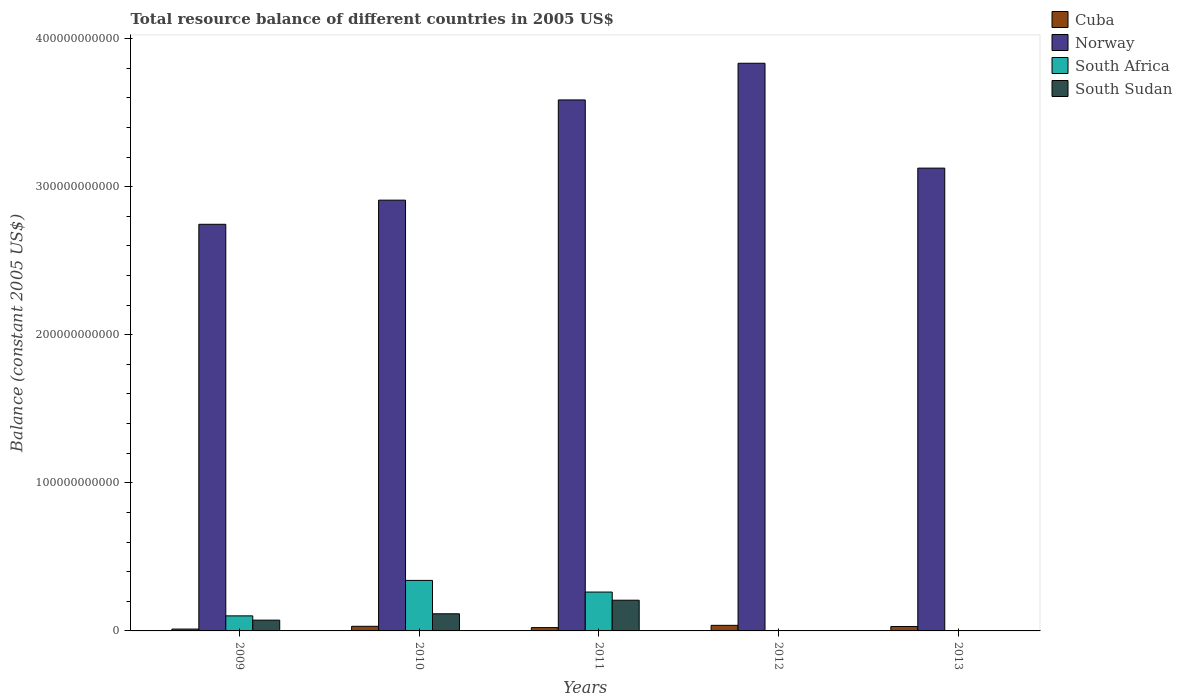How many different coloured bars are there?
Ensure brevity in your answer.  4. Are the number of bars per tick equal to the number of legend labels?
Offer a terse response. No. Are the number of bars on each tick of the X-axis equal?
Your response must be concise. No. What is the total resource balance in Norway in 2009?
Provide a short and direct response. 2.75e+11. Across all years, what is the maximum total resource balance in Cuba?
Offer a very short reply. 3.77e+09. Across all years, what is the minimum total resource balance in Cuba?
Your answer should be very brief. 1.25e+09. What is the total total resource balance in South Sudan in the graph?
Your answer should be compact. 3.96e+1. What is the difference between the total resource balance in Cuba in 2010 and that in 2012?
Provide a succinct answer. -6.53e+08. What is the difference between the total resource balance in Cuba in 2011 and the total resource balance in South Sudan in 2012?
Offer a terse response. 2.24e+09. What is the average total resource balance in South Sudan per year?
Provide a succinct answer. 7.92e+09. In the year 2010, what is the difference between the total resource balance in South Sudan and total resource balance in Cuba?
Offer a terse response. 8.45e+09. What is the ratio of the total resource balance in Norway in 2010 to that in 2012?
Offer a terse response. 0.76. Is the total resource balance in Cuba in 2011 less than that in 2013?
Offer a very short reply. Yes. What is the difference between the highest and the second highest total resource balance in South Sudan?
Make the answer very short. 9.17e+09. What is the difference between the highest and the lowest total resource balance in South Sudan?
Offer a terse response. 2.07e+1. In how many years, is the total resource balance in South Africa greater than the average total resource balance in South Africa taken over all years?
Your answer should be compact. 2. Is the sum of the total resource balance in South Africa in 2009 and 2010 greater than the maximum total resource balance in Norway across all years?
Provide a succinct answer. No. Is it the case that in every year, the sum of the total resource balance in South Africa and total resource balance in Cuba is greater than the sum of total resource balance in South Sudan and total resource balance in Norway?
Offer a very short reply. No. How many bars are there?
Your answer should be compact. 16. What is the difference between two consecutive major ticks on the Y-axis?
Ensure brevity in your answer.  1.00e+11. Are the values on the major ticks of Y-axis written in scientific E-notation?
Offer a very short reply. No. How many legend labels are there?
Your response must be concise. 4. How are the legend labels stacked?
Ensure brevity in your answer.  Vertical. What is the title of the graph?
Provide a succinct answer. Total resource balance of different countries in 2005 US$. Does "American Samoa" appear as one of the legend labels in the graph?
Provide a succinct answer. No. What is the label or title of the X-axis?
Keep it short and to the point. Years. What is the label or title of the Y-axis?
Provide a succinct answer. Balance (constant 2005 US$). What is the Balance (constant 2005 US$) of Cuba in 2009?
Offer a terse response. 1.25e+09. What is the Balance (constant 2005 US$) of Norway in 2009?
Give a very brief answer. 2.75e+11. What is the Balance (constant 2005 US$) of South Africa in 2009?
Ensure brevity in your answer.  1.02e+1. What is the Balance (constant 2005 US$) of South Sudan in 2009?
Your response must be concise. 7.29e+09. What is the Balance (constant 2005 US$) in Cuba in 2010?
Offer a very short reply. 3.12e+09. What is the Balance (constant 2005 US$) in Norway in 2010?
Provide a short and direct response. 2.91e+11. What is the Balance (constant 2005 US$) of South Africa in 2010?
Give a very brief answer. 3.41e+1. What is the Balance (constant 2005 US$) in South Sudan in 2010?
Give a very brief answer. 1.16e+1. What is the Balance (constant 2005 US$) in Cuba in 2011?
Offer a very short reply. 2.24e+09. What is the Balance (constant 2005 US$) in Norway in 2011?
Give a very brief answer. 3.59e+11. What is the Balance (constant 2005 US$) in South Africa in 2011?
Make the answer very short. 2.62e+1. What is the Balance (constant 2005 US$) of South Sudan in 2011?
Offer a very short reply. 2.07e+1. What is the Balance (constant 2005 US$) of Cuba in 2012?
Provide a succinct answer. 3.77e+09. What is the Balance (constant 2005 US$) in Norway in 2012?
Provide a short and direct response. 3.83e+11. What is the Balance (constant 2005 US$) in Cuba in 2013?
Offer a very short reply. 2.99e+09. What is the Balance (constant 2005 US$) of Norway in 2013?
Make the answer very short. 3.13e+11. What is the Balance (constant 2005 US$) of South Africa in 2013?
Your answer should be compact. 0. Across all years, what is the maximum Balance (constant 2005 US$) of Cuba?
Provide a short and direct response. 3.77e+09. Across all years, what is the maximum Balance (constant 2005 US$) of Norway?
Provide a short and direct response. 3.83e+11. Across all years, what is the maximum Balance (constant 2005 US$) of South Africa?
Offer a very short reply. 3.41e+1. Across all years, what is the maximum Balance (constant 2005 US$) in South Sudan?
Keep it short and to the point. 2.07e+1. Across all years, what is the minimum Balance (constant 2005 US$) of Cuba?
Provide a succinct answer. 1.25e+09. Across all years, what is the minimum Balance (constant 2005 US$) of Norway?
Offer a terse response. 2.75e+11. Across all years, what is the minimum Balance (constant 2005 US$) in South Africa?
Offer a terse response. 0. What is the total Balance (constant 2005 US$) of Cuba in the graph?
Your response must be concise. 1.34e+1. What is the total Balance (constant 2005 US$) in Norway in the graph?
Make the answer very short. 1.62e+12. What is the total Balance (constant 2005 US$) in South Africa in the graph?
Give a very brief answer. 7.05e+1. What is the total Balance (constant 2005 US$) of South Sudan in the graph?
Give a very brief answer. 3.96e+1. What is the difference between the Balance (constant 2005 US$) in Cuba in 2009 and that in 2010?
Make the answer very short. -1.87e+09. What is the difference between the Balance (constant 2005 US$) of Norway in 2009 and that in 2010?
Provide a short and direct response. -1.63e+1. What is the difference between the Balance (constant 2005 US$) in South Africa in 2009 and that in 2010?
Your answer should be compact. -2.39e+1. What is the difference between the Balance (constant 2005 US$) of South Sudan in 2009 and that in 2010?
Make the answer very short. -4.29e+09. What is the difference between the Balance (constant 2005 US$) in Cuba in 2009 and that in 2011?
Offer a very short reply. -9.94e+08. What is the difference between the Balance (constant 2005 US$) of Norway in 2009 and that in 2011?
Make the answer very short. -8.40e+1. What is the difference between the Balance (constant 2005 US$) in South Africa in 2009 and that in 2011?
Offer a very short reply. -1.61e+1. What is the difference between the Balance (constant 2005 US$) in South Sudan in 2009 and that in 2011?
Ensure brevity in your answer.  -1.35e+1. What is the difference between the Balance (constant 2005 US$) in Cuba in 2009 and that in 2012?
Offer a very short reply. -2.53e+09. What is the difference between the Balance (constant 2005 US$) of Norway in 2009 and that in 2012?
Your answer should be compact. -1.09e+11. What is the difference between the Balance (constant 2005 US$) of Cuba in 2009 and that in 2013?
Offer a terse response. -1.75e+09. What is the difference between the Balance (constant 2005 US$) of Norway in 2009 and that in 2013?
Ensure brevity in your answer.  -3.79e+1. What is the difference between the Balance (constant 2005 US$) of Cuba in 2010 and that in 2011?
Provide a short and direct response. 8.79e+08. What is the difference between the Balance (constant 2005 US$) of Norway in 2010 and that in 2011?
Provide a succinct answer. -6.77e+1. What is the difference between the Balance (constant 2005 US$) in South Africa in 2010 and that in 2011?
Make the answer very short. 7.87e+09. What is the difference between the Balance (constant 2005 US$) of South Sudan in 2010 and that in 2011?
Your answer should be very brief. -9.17e+09. What is the difference between the Balance (constant 2005 US$) of Cuba in 2010 and that in 2012?
Your response must be concise. -6.53e+08. What is the difference between the Balance (constant 2005 US$) of Norway in 2010 and that in 2012?
Provide a short and direct response. -9.24e+1. What is the difference between the Balance (constant 2005 US$) of Cuba in 2010 and that in 2013?
Ensure brevity in your answer.  1.27e+08. What is the difference between the Balance (constant 2005 US$) of Norway in 2010 and that in 2013?
Your response must be concise. -2.16e+1. What is the difference between the Balance (constant 2005 US$) in Cuba in 2011 and that in 2012?
Give a very brief answer. -1.53e+09. What is the difference between the Balance (constant 2005 US$) of Norway in 2011 and that in 2012?
Provide a succinct answer. -2.48e+1. What is the difference between the Balance (constant 2005 US$) in Cuba in 2011 and that in 2013?
Keep it short and to the point. -7.51e+08. What is the difference between the Balance (constant 2005 US$) of Norway in 2011 and that in 2013?
Provide a succinct answer. 4.60e+1. What is the difference between the Balance (constant 2005 US$) of Cuba in 2012 and that in 2013?
Make the answer very short. 7.80e+08. What is the difference between the Balance (constant 2005 US$) of Norway in 2012 and that in 2013?
Provide a short and direct response. 7.08e+1. What is the difference between the Balance (constant 2005 US$) in Cuba in 2009 and the Balance (constant 2005 US$) in Norway in 2010?
Keep it short and to the point. -2.90e+11. What is the difference between the Balance (constant 2005 US$) of Cuba in 2009 and the Balance (constant 2005 US$) of South Africa in 2010?
Offer a terse response. -3.29e+1. What is the difference between the Balance (constant 2005 US$) in Cuba in 2009 and the Balance (constant 2005 US$) in South Sudan in 2010?
Your answer should be compact. -1.03e+1. What is the difference between the Balance (constant 2005 US$) of Norway in 2009 and the Balance (constant 2005 US$) of South Africa in 2010?
Your response must be concise. 2.40e+11. What is the difference between the Balance (constant 2005 US$) of Norway in 2009 and the Balance (constant 2005 US$) of South Sudan in 2010?
Offer a terse response. 2.63e+11. What is the difference between the Balance (constant 2005 US$) of South Africa in 2009 and the Balance (constant 2005 US$) of South Sudan in 2010?
Your answer should be compact. -1.40e+09. What is the difference between the Balance (constant 2005 US$) in Cuba in 2009 and the Balance (constant 2005 US$) in Norway in 2011?
Offer a terse response. -3.57e+11. What is the difference between the Balance (constant 2005 US$) of Cuba in 2009 and the Balance (constant 2005 US$) of South Africa in 2011?
Ensure brevity in your answer.  -2.50e+1. What is the difference between the Balance (constant 2005 US$) in Cuba in 2009 and the Balance (constant 2005 US$) in South Sudan in 2011?
Your response must be concise. -1.95e+1. What is the difference between the Balance (constant 2005 US$) in Norway in 2009 and the Balance (constant 2005 US$) in South Africa in 2011?
Keep it short and to the point. 2.48e+11. What is the difference between the Balance (constant 2005 US$) in Norway in 2009 and the Balance (constant 2005 US$) in South Sudan in 2011?
Make the answer very short. 2.54e+11. What is the difference between the Balance (constant 2005 US$) of South Africa in 2009 and the Balance (constant 2005 US$) of South Sudan in 2011?
Provide a succinct answer. -1.06e+1. What is the difference between the Balance (constant 2005 US$) in Cuba in 2009 and the Balance (constant 2005 US$) in Norway in 2012?
Ensure brevity in your answer.  -3.82e+11. What is the difference between the Balance (constant 2005 US$) of Cuba in 2009 and the Balance (constant 2005 US$) of Norway in 2013?
Ensure brevity in your answer.  -3.11e+11. What is the difference between the Balance (constant 2005 US$) in Cuba in 2010 and the Balance (constant 2005 US$) in Norway in 2011?
Provide a succinct answer. -3.55e+11. What is the difference between the Balance (constant 2005 US$) in Cuba in 2010 and the Balance (constant 2005 US$) in South Africa in 2011?
Keep it short and to the point. -2.31e+1. What is the difference between the Balance (constant 2005 US$) of Cuba in 2010 and the Balance (constant 2005 US$) of South Sudan in 2011?
Your answer should be compact. -1.76e+1. What is the difference between the Balance (constant 2005 US$) of Norway in 2010 and the Balance (constant 2005 US$) of South Africa in 2011?
Ensure brevity in your answer.  2.65e+11. What is the difference between the Balance (constant 2005 US$) in Norway in 2010 and the Balance (constant 2005 US$) in South Sudan in 2011?
Ensure brevity in your answer.  2.70e+11. What is the difference between the Balance (constant 2005 US$) of South Africa in 2010 and the Balance (constant 2005 US$) of South Sudan in 2011?
Make the answer very short. 1.34e+1. What is the difference between the Balance (constant 2005 US$) of Cuba in 2010 and the Balance (constant 2005 US$) of Norway in 2012?
Your answer should be very brief. -3.80e+11. What is the difference between the Balance (constant 2005 US$) of Cuba in 2010 and the Balance (constant 2005 US$) of Norway in 2013?
Make the answer very short. -3.09e+11. What is the difference between the Balance (constant 2005 US$) in Cuba in 2011 and the Balance (constant 2005 US$) in Norway in 2012?
Your answer should be compact. -3.81e+11. What is the difference between the Balance (constant 2005 US$) of Cuba in 2011 and the Balance (constant 2005 US$) of Norway in 2013?
Keep it short and to the point. -3.10e+11. What is the difference between the Balance (constant 2005 US$) in Cuba in 2012 and the Balance (constant 2005 US$) in Norway in 2013?
Your response must be concise. -3.09e+11. What is the average Balance (constant 2005 US$) in Cuba per year?
Your response must be concise. 2.67e+09. What is the average Balance (constant 2005 US$) of Norway per year?
Your answer should be compact. 3.24e+11. What is the average Balance (constant 2005 US$) in South Africa per year?
Give a very brief answer. 1.41e+1. What is the average Balance (constant 2005 US$) of South Sudan per year?
Your answer should be compact. 7.92e+09. In the year 2009, what is the difference between the Balance (constant 2005 US$) of Cuba and Balance (constant 2005 US$) of Norway?
Keep it short and to the point. -2.73e+11. In the year 2009, what is the difference between the Balance (constant 2005 US$) of Cuba and Balance (constant 2005 US$) of South Africa?
Offer a terse response. -8.92e+09. In the year 2009, what is the difference between the Balance (constant 2005 US$) of Cuba and Balance (constant 2005 US$) of South Sudan?
Your answer should be very brief. -6.04e+09. In the year 2009, what is the difference between the Balance (constant 2005 US$) of Norway and Balance (constant 2005 US$) of South Africa?
Your answer should be very brief. 2.64e+11. In the year 2009, what is the difference between the Balance (constant 2005 US$) in Norway and Balance (constant 2005 US$) in South Sudan?
Your response must be concise. 2.67e+11. In the year 2009, what is the difference between the Balance (constant 2005 US$) in South Africa and Balance (constant 2005 US$) in South Sudan?
Keep it short and to the point. 2.88e+09. In the year 2010, what is the difference between the Balance (constant 2005 US$) in Cuba and Balance (constant 2005 US$) in Norway?
Give a very brief answer. -2.88e+11. In the year 2010, what is the difference between the Balance (constant 2005 US$) in Cuba and Balance (constant 2005 US$) in South Africa?
Keep it short and to the point. -3.10e+1. In the year 2010, what is the difference between the Balance (constant 2005 US$) of Cuba and Balance (constant 2005 US$) of South Sudan?
Provide a short and direct response. -8.45e+09. In the year 2010, what is the difference between the Balance (constant 2005 US$) of Norway and Balance (constant 2005 US$) of South Africa?
Offer a terse response. 2.57e+11. In the year 2010, what is the difference between the Balance (constant 2005 US$) in Norway and Balance (constant 2005 US$) in South Sudan?
Provide a short and direct response. 2.79e+11. In the year 2010, what is the difference between the Balance (constant 2005 US$) in South Africa and Balance (constant 2005 US$) in South Sudan?
Your answer should be very brief. 2.25e+1. In the year 2011, what is the difference between the Balance (constant 2005 US$) of Cuba and Balance (constant 2005 US$) of Norway?
Ensure brevity in your answer.  -3.56e+11. In the year 2011, what is the difference between the Balance (constant 2005 US$) in Cuba and Balance (constant 2005 US$) in South Africa?
Give a very brief answer. -2.40e+1. In the year 2011, what is the difference between the Balance (constant 2005 US$) of Cuba and Balance (constant 2005 US$) of South Sudan?
Your response must be concise. -1.85e+1. In the year 2011, what is the difference between the Balance (constant 2005 US$) of Norway and Balance (constant 2005 US$) of South Africa?
Offer a very short reply. 3.32e+11. In the year 2011, what is the difference between the Balance (constant 2005 US$) of Norway and Balance (constant 2005 US$) of South Sudan?
Your answer should be very brief. 3.38e+11. In the year 2011, what is the difference between the Balance (constant 2005 US$) in South Africa and Balance (constant 2005 US$) in South Sudan?
Keep it short and to the point. 5.50e+09. In the year 2012, what is the difference between the Balance (constant 2005 US$) in Cuba and Balance (constant 2005 US$) in Norway?
Ensure brevity in your answer.  -3.80e+11. In the year 2013, what is the difference between the Balance (constant 2005 US$) in Cuba and Balance (constant 2005 US$) in Norway?
Give a very brief answer. -3.10e+11. What is the ratio of the Balance (constant 2005 US$) of Cuba in 2009 to that in 2010?
Provide a succinct answer. 0.4. What is the ratio of the Balance (constant 2005 US$) of Norway in 2009 to that in 2010?
Ensure brevity in your answer.  0.94. What is the ratio of the Balance (constant 2005 US$) of South Africa in 2009 to that in 2010?
Your answer should be compact. 0.3. What is the ratio of the Balance (constant 2005 US$) in South Sudan in 2009 to that in 2010?
Make the answer very short. 0.63. What is the ratio of the Balance (constant 2005 US$) in Cuba in 2009 to that in 2011?
Your answer should be very brief. 0.56. What is the ratio of the Balance (constant 2005 US$) in Norway in 2009 to that in 2011?
Provide a succinct answer. 0.77. What is the ratio of the Balance (constant 2005 US$) of South Africa in 2009 to that in 2011?
Keep it short and to the point. 0.39. What is the ratio of the Balance (constant 2005 US$) in South Sudan in 2009 to that in 2011?
Your response must be concise. 0.35. What is the ratio of the Balance (constant 2005 US$) of Cuba in 2009 to that in 2012?
Your answer should be compact. 0.33. What is the ratio of the Balance (constant 2005 US$) of Norway in 2009 to that in 2012?
Give a very brief answer. 0.72. What is the ratio of the Balance (constant 2005 US$) of Cuba in 2009 to that in 2013?
Provide a succinct answer. 0.42. What is the ratio of the Balance (constant 2005 US$) of Norway in 2009 to that in 2013?
Offer a terse response. 0.88. What is the ratio of the Balance (constant 2005 US$) of Cuba in 2010 to that in 2011?
Offer a terse response. 1.39. What is the ratio of the Balance (constant 2005 US$) in Norway in 2010 to that in 2011?
Offer a very short reply. 0.81. What is the ratio of the Balance (constant 2005 US$) of South Sudan in 2010 to that in 2011?
Provide a short and direct response. 0.56. What is the ratio of the Balance (constant 2005 US$) of Cuba in 2010 to that in 2012?
Offer a terse response. 0.83. What is the ratio of the Balance (constant 2005 US$) of Norway in 2010 to that in 2012?
Provide a succinct answer. 0.76. What is the ratio of the Balance (constant 2005 US$) in Cuba in 2010 to that in 2013?
Provide a succinct answer. 1.04. What is the ratio of the Balance (constant 2005 US$) in Norway in 2010 to that in 2013?
Your answer should be compact. 0.93. What is the ratio of the Balance (constant 2005 US$) of Cuba in 2011 to that in 2012?
Give a very brief answer. 0.59. What is the ratio of the Balance (constant 2005 US$) in Norway in 2011 to that in 2012?
Offer a terse response. 0.94. What is the ratio of the Balance (constant 2005 US$) in Cuba in 2011 to that in 2013?
Keep it short and to the point. 0.75. What is the ratio of the Balance (constant 2005 US$) in Norway in 2011 to that in 2013?
Ensure brevity in your answer.  1.15. What is the ratio of the Balance (constant 2005 US$) of Cuba in 2012 to that in 2013?
Offer a terse response. 1.26. What is the ratio of the Balance (constant 2005 US$) of Norway in 2012 to that in 2013?
Your answer should be compact. 1.23. What is the difference between the highest and the second highest Balance (constant 2005 US$) of Cuba?
Ensure brevity in your answer.  6.53e+08. What is the difference between the highest and the second highest Balance (constant 2005 US$) in Norway?
Provide a succinct answer. 2.48e+1. What is the difference between the highest and the second highest Balance (constant 2005 US$) in South Africa?
Give a very brief answer. 7.87e+09. What is the difference between the highest and the second highest Balance (constant 2005 US$) in South Sudan?
Ensure brevity in your answer.  9.17e+09. What is the difference between the highest and the lowest Balance (constant 2005 US$) in Cuba?
Keep it short and to the point. 2.53e+09. What is the difference between the highest and the lowest Balance (constant 2005 US$) of Norway?
Make the answer very short. 1.09e+11. What is the difference between the highest and the lowest Balance (constant 2005 US$) of South Africa?
Keep it short and to the point. 3.41e+1. What is the difference between the highest and the lowest Balance (constant 2005 US$) of South Sudan?
Offer a very short reply. 2.07e+1. 